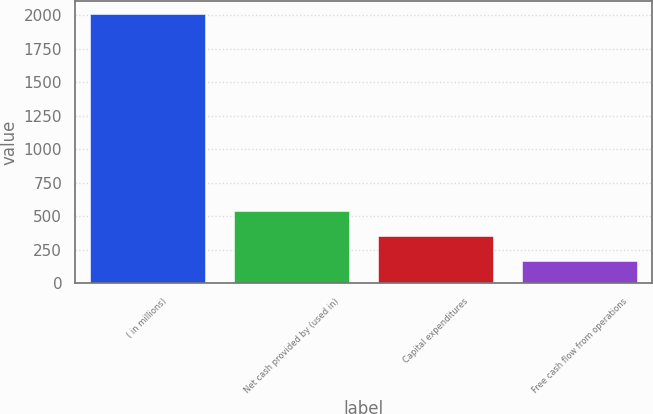<chart> <loc_0><loc_0><loc_500><loc_500><bar_chart><fcel>( in millions)<fcel>Net cash provided by (used in)<fcel>Capital expenditures<fcel>Free cash flow from operations<nl><fcel>2010<fcel>536.4<fcel>352.2<fcel>168<nl></chart> 